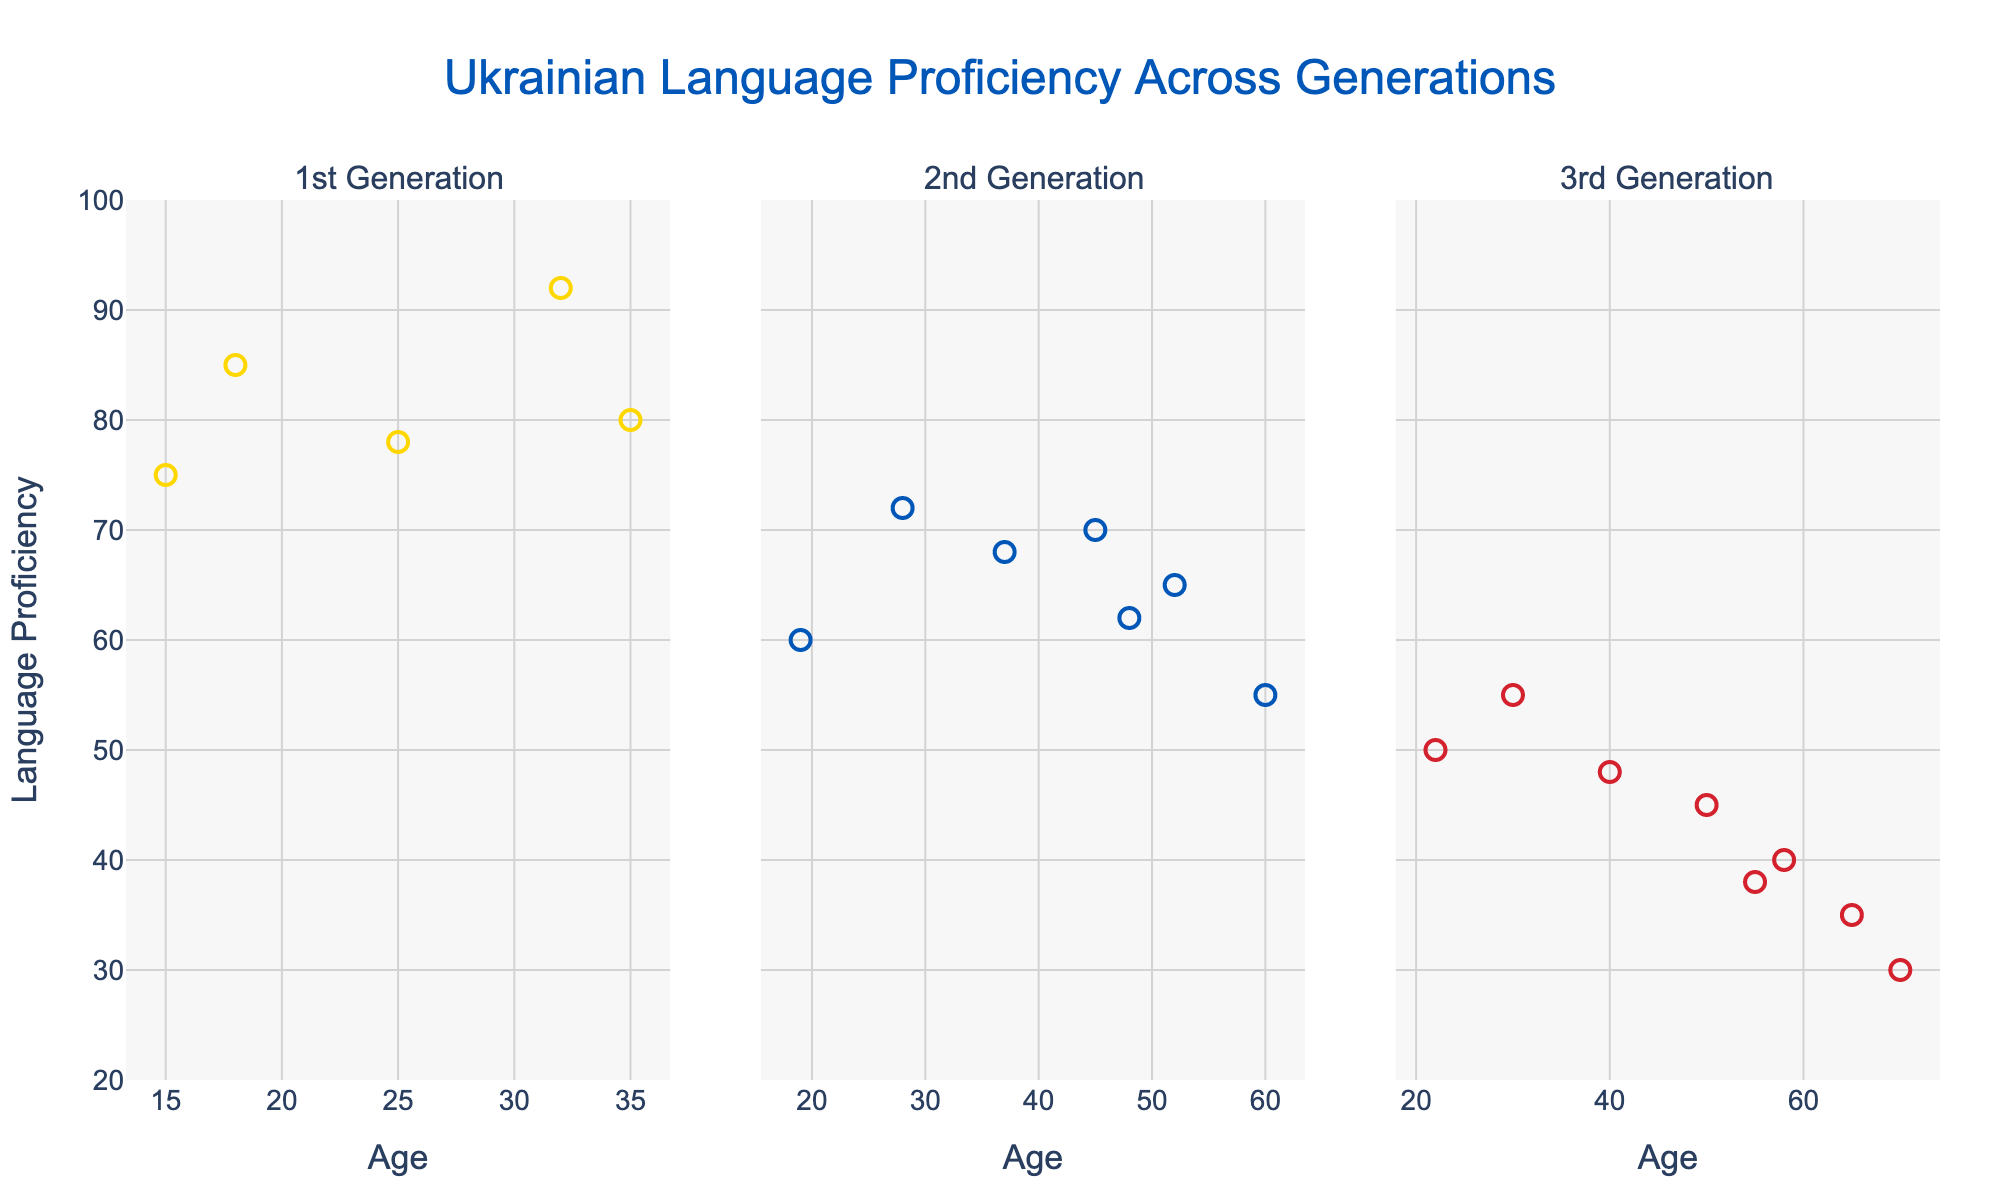What is the title of the figure? The title of the figure is displayed prominently at the top of the figure. It reads "Impact of Social Media on Mental Health".
Answer: Impact of Social Media on Mental Health Which generation has the highest average daily social media usage? The bar plot in the bottom right shows average daily social media usage by generation. The tallest bar corresponds to Gen Z.
Answer: Gen Z What is the range of ages represented in the figure? The x-axis of the top-left and top-right scatter plots show the age range from the youngest at 13 to the oldest at 72.
Answer: 13 to 72 Which social media platform is associated with the highest depression score and what is the score? In the top-right scatter plot, the marker with the highest depression score, 35, corresponds to Instagram.
Answer: Instagram, 35 How does social media usage vary with age according to the data? In the top-left scatter plot, looking at the trend from left to right (youngest to oldest), the markers generally decrease in height, suggesting social media usage decreases with age.
Answer: Decreases with age Is there any generation that has an average daily social media usage of over 4 hours? The bottom right bar plot shows the average daily social media usage for each generation. No bar exceeds 4 hours.
Answer: No What is the depression score for someone who uses Facebook and is 25 years old? In the top-right scatter plot, locate the marker for Facebook at age 25. The associated depression score is 15.
Answer: 15 Among the generations displayed, which one has the lowest social media usage, and what is the average daily usage for that generation? The bottom right bar plot indicates Baby Boomers have the lowest average daily social media usage, approximately 0.45 hours.
Answer: Baby Boomers, 0.45 hours Is there a positive correlation between daily social media usage and depression score across all age groups? In the scatter plot at the bottom left, there seems to be a general upward trend as you move right (higher daily social media usage) and upward (higher depression score), indicating a positive correlation.
Answer: Yes What can be observed about the depression scores of individuals aged 32 and older? In the top-right scatter plot, markers representing individuals aged 32 and older are clustered in the lower depression score range (below 10).
Answer: Clustered below 10 